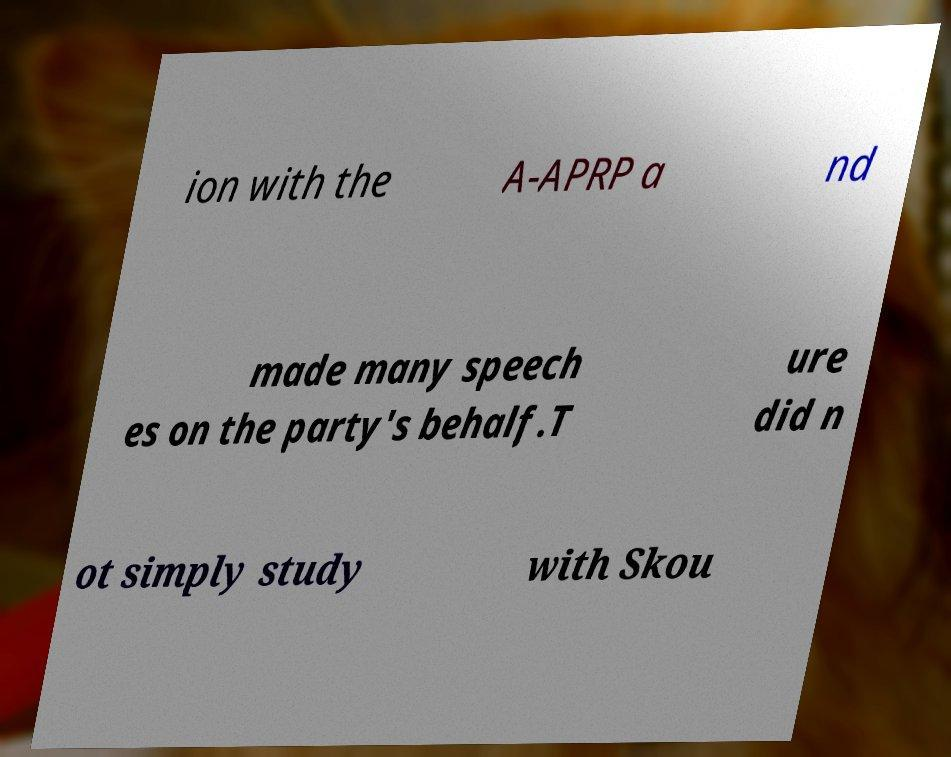Please read and relay the text visible in this image. What does it say? ion with the A-APRP a nd made many speech es on the party's behalf.T ure did n ot simply study with Skou 